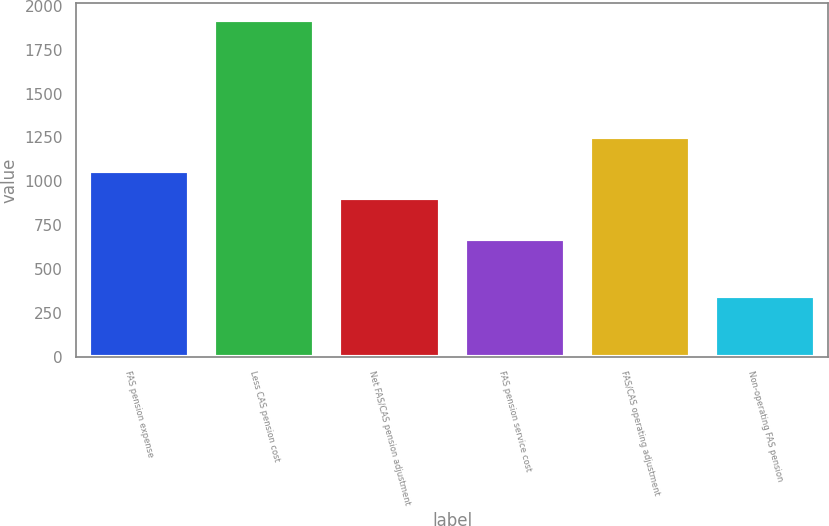<chart> <loc_0><loc_0><loc_500><loc_500><bar_chart><fcel>FAS pension expense<fcel>Less CAS pension cost<fcel>Net FAS/CAS pension adjustment<fcel>FAS pension service cost<fcel>FAS/CAS operating adjustment<fcel>Non-operating FAS pension<nl><fcel>1059.3<fcel>1921<fcel>902<fcel>671<fcel>1250<fcel>348<nl></chart> 